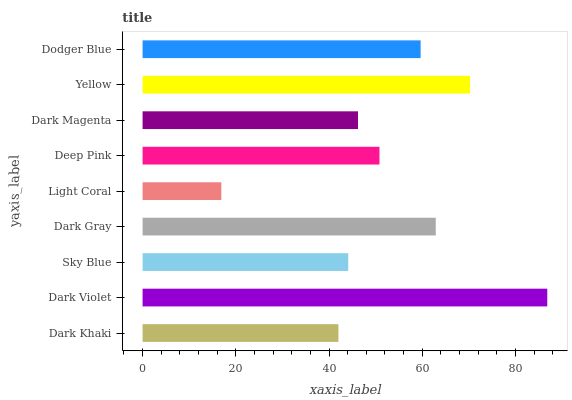Is Light Coral the minimum?
Answer yes or no. Yes. Is Dark Violet the maximum?
Answer yes or no. Yes. Is Sky Blue the minimum?
Answer yes or no. No. Is Sky Blue the maximum?
Answer yes or no. No. Is Dark Violet greater than Sky Blue?
Answer yes or no. Yes. Is Sky Blue less than Dark Violet?
Answer yes or no. Yes. Is Sky Blue greater than Dark Violet?
Answer yes or no. No. Is Dark Violet less than Sky Blue?
Answer yes or no. No. Is Deep Pink the high median?
Answer yes or no. Yes. Is Deep Pink the low median?
Answer yes or no. Yes. Is Dark Violet the high median?
Answer yes or no. No. Is Yellow the low median?
Answer yes or no. No. 